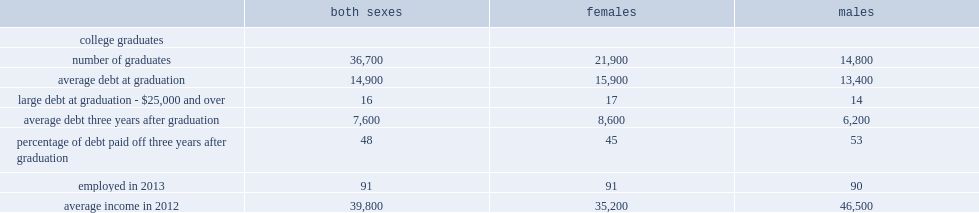What was the average debt of female college graduates had at graduation? 15900.0. What was the average debt of male college graduates had at graduation? 13400.0. Which gender college graduates had more average debt at graduation, male or female? Females. What was the percentage of men who had not repaid as much of their student debt? 53.0. What was the percentage of women who had not repaid as much of their student debt? 45.0. What was the average debt women owed after 3-year graduation? 8600.0. What was the average debt men owed after 3-year graduation? 6200.0. What was the average income that female college students had after 3-year graduation? 35200.0. What was the average income that male college students had after 3-year graduation? 46500.0. Which gender college graduates had more average income after 3-year graduation, male or female? Males. 